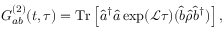<formula> <loc_0><loc_0><loc_500><loc_500>G _ { a b } ^ { ( 2 ) } ( t , \tau ) = T r \left [ \hat { a } ^ { \dagger } \hat { a } \exp ( \mathcal { L } \tau ) ( \hat { b } \hat { \rho } \hat { b } ^ { \dagger } ) \right ] ,</formula> 